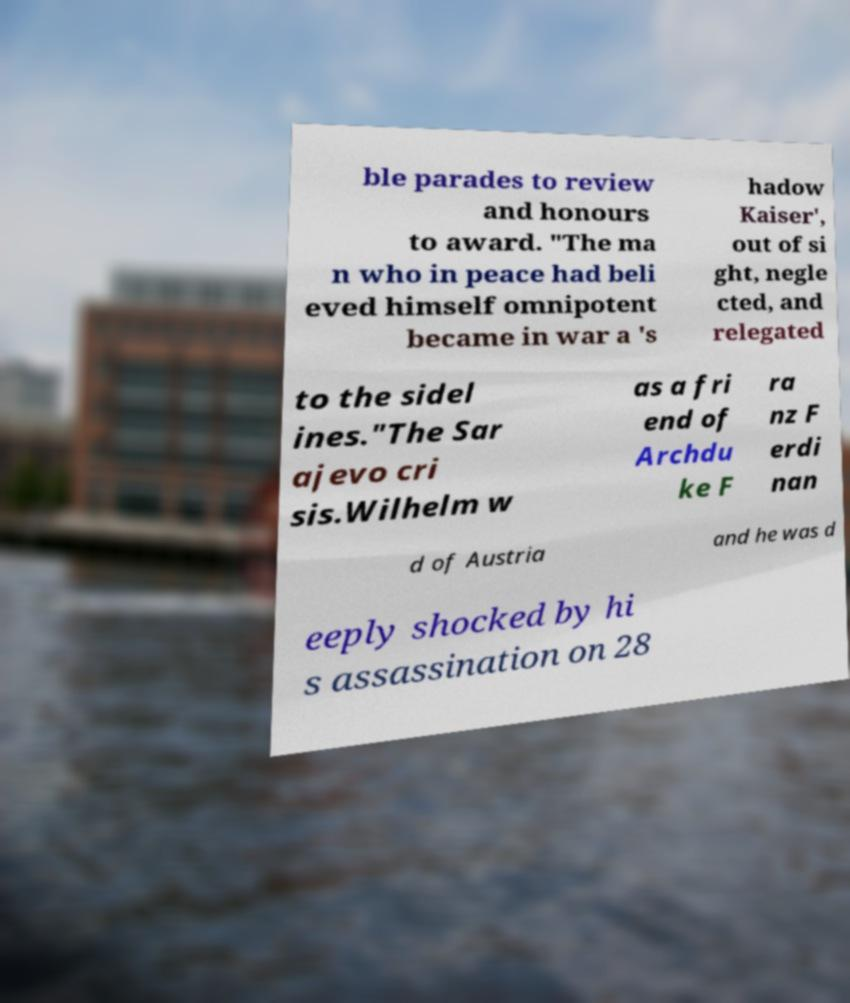Could you assist in decoding the text presented in this image and type it out clearly? ble parades to review and honours to award. "The ma n who in peace had beli eved himself omnipotent became in war a 's hadow Kaiser', out of si ght, negle cted, and relegated to the sidel ines."The Sar ajevo cri sis.Wilhelm w as a fri end of Archdu ke F ra nz F erdi nan d of Austria and he was d eeply shocked by hi s assassination on 28 